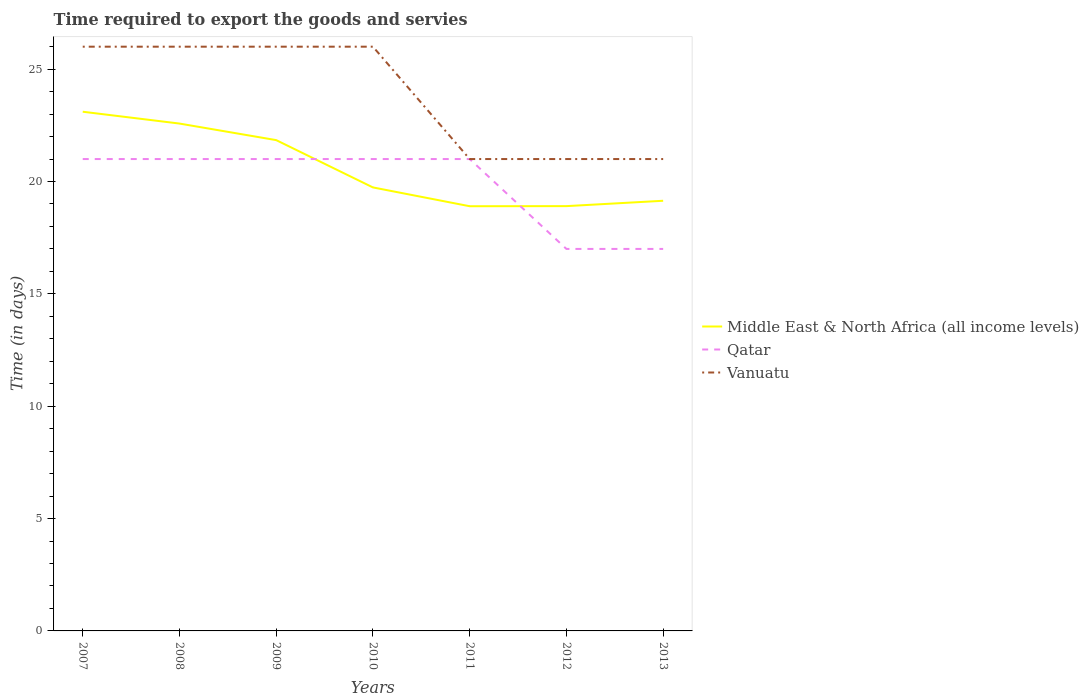Does the line corresponding to Vanuatu intersect with the line corresponding to Qatar?
Give a very brief answer. Yes. Is the number of lines equal to the number of legend labels?
Provide a short and direct response. Yes. Across all years, what is the maximum number of days required to export the goods and services in Vanuatu?
Give a very brief answer. 21. What is the total number of days required to export the goods and services in Middle East & North Africa (all income levels) in the graph?
Make the answer very short. 3.96. What is the difference between the highest and the second highest number of days required to export the goods and services in Vanuatu?
Give a very brief answer. 5. What is the difference between the highest and the lowest number of days required to export the goods and services in Vanuatu?
Give a very brief answer. 4. Is the number of days required to export the goods and services in Qatar strictly greater than the number of days required to export the goods and services in Middle East & North Africa (all income levels) over the years?
Provide a short and direct response. No. How many lines are there?
Your response must be concise. 3. How many years are there in the graph?
Your answer should be very brief. 7. What is the difference between two consecutive major ticks on the Y-axis?
Provide a succinct answer. 5. Are the values on the major ticks of Y-axis written in scientific E-notation?
Give a very brief answer. No. Does the graph contain any zero values?
Provide a succinct answer. No. Where does the legend appear in the graph?
Keep it short and to the point. Center right. How are the legend labels stacked?
Offer a terse response. Vertical. What is the title of the graph?
Your answer should be compact. Time required to export the goods and servies. Does "Monaco" appear as one of the legend labels in the graph?
Provide a succinct answer. No. What is the label or title of the Y-axis?
Your response must be concise. Time (in days). What is the Time (in days) in Middle East & North Africa (all income levels) in 2007?
Offer a very short reply. 23.11. What is the Time (in days) of Vanuatu in 2007?
Offer a terse response. 26. What is the Time (in days) of Middle East & North Africa (all income levels) in 2008?
Keep it short and to the point. 22.58. What is the Time (in days) of Middle East & North Africa (all income levels) in 2009?
Make the answer very short. 21.84. What is the Time (in days) in Qatar in 2009?
Keep it short and to the point. 21. What is the Time (in days) of Middle East & North Africa (all income levels) in 2010?
Your response must be concise. 19.74. What is the Time (in days) in Vanuatu in 2010?
Offer a very short reply. 26. What is the Time (in days) in Qatar in 2011?
Give a very brief answer. 21. What is the Time (in days) in Middle East & North Africa (all income levels) in 2012?
Offer a terse response. 18.9. What is the Time (in days) in Qatar in 2012?
Offer a terse response. 17. What is the Time (in days) of Middle East & North Africa (all income levels) in 2013?
Make the answer very short. 19.14. What is the Time (in days) of Qatar in 2013?
Provide a succinct answer. 17. What is the Time (in days) in Vanuatu in 2013?
Offer a terse response. 21. Across all years, what is the maximum Time (in days) of Middle East & North Africa (all income levels)?
Make the answer very short. 23.11. Across all years, what is the maximum Time (in days) in Qatar?
Provide a succinct answer. 21. Across all years, what is the maximum Time (in days) of Vanuatu?
Give a very brief answer. 26. Across all years, what is the minimum Time (in days) in Middle East & North Africa (all income levels)?
Your answer should be very brief. 18.9. Across all years, what is the minimum Time (in days) of Qatar?
Keep it short and to the point. 17. What is the total Time (in days) of Middle East & North Africa (all income levels) in the graph?
Your answer should be very brief. 144.21. What is the total Time (in days) of Qatar in the graph?
Your response must be concise. 139. What is the total Time (in days) in Vanuatu in the graph?
Make the answer very short. 167. What is the difference between the Time (in days) of Middle East & North Africa (all income levels) in 2007 and that in 2008?
Make the answer very short. 0.53. What is the difference between the Time (in days) in Vanuatu in 2007 and that in 2008?
Keep it short and to the point. 0. What is the difference between the Time (in days) in Middle East & North Africa (all income levels) in 2007 and that in 2009?
Make the answer very short. 1.26. What is the difference between the Time (in days) of Qatar in 2007 and that in 2009?
Offer a terse response. 0. What is the difference between the Time (in days) of Middle East & North Africa (all income levels) in 2007 and that in 2010?
Keep it short and to the point. 3.37. What is the difference between the Time (in days) in Middle East & North Africa (all income levels) in 2007 and that in 2011?
Provide a succinct answer. 4.21. What is the difference between the Time (in days) of Qatar in 2007 and that in 2011?
Ensure brevity in your answer.  0. What is the difference between the Time (in days) in Vanuatu in 2007 and that in 2011?
Offer a terse response. 5. What is the difference between the Time (in days) of Middle East & North Africa (all income levels) in 2007 and that in 2012?
Keep it short and to the point. 4.2. What is the difference between the Time (in days) of Middle East & North Africa (all income levels) in 2007 and that in 2013?
Ensure brevity in your answer.  3.96. What is the difference between the Time (in days) of Vanuatu in 2007 and that in 2013?
Your response must be concise. 5. What is the difference between the Time (in days) in Middle East & North Africa (all income levels) in 2008 and that in 2009?
Your response must be concise. 0.74. What is the difference between the Time (in days) of Vanuatu in 2008 and that in 2009?
Offer a terse response. 0. What is the difference between the Time (in days) in Middle East & North Africa (all income levels) in 2008 and that in 2010?
Your response must be concise. 2.84. What is the difference between the Time (in days) of Middle East & North Africa (all income levels) in 2008 and that in 2011?
Your answer should be very brief. 3.68. What is the difference between the Time (in days) of Qatar in 2008 and that in 2011?
Your answer should be compact. 0. What is the difference between the Time (in days) of Vanuatu in 2008 and that in 2011?
Offer a very short reply. 5. What is the difference between the Time (in days) in Middle East & North Africa (all income levels) in 2008 and that in 2012?
Provide a short and direct response. 3.67. What is the difference between the Time (in days) in Middle East & North Africa (all income levels) in 2008 and that in 2013?
Give a very brief answer. 3.44. What is the difference between the Time (in days) of Middle East & North Africa (all income levels) in 2009 and that in 2010?
Keep it short and to the point. 2.11. What is the difference between the Time (in days) in Vanuatu in 2009 and that in 2010?
Offer a terse response. 0. What is the difference between the Time (in days) in Middle East & North Africa (all income levels) in 2009 and that in 2011?
Your answer should be very brief. 2.94. What is the difference between the Time (in days) in Middle East & North Africa (all income levels) in 2009 and that in 2012?
Your response must be concise. 2.94. What is the difference between the Time (in days) of Middle East & North Africa (all income levels) in 2009 and that in 2013?
Your answer should be very brief. 2.7. What is the difference between the Time (in days) in Qatar in 2009 and that in 2013?
Your response must be concise. 4. What is the difference between the Time (in days) in Middle East & North Africa (all income levels) in 2010 and that in 2011?
Give a very brief answer. 0.84. What is the difference between the Time (in days) in Middle East & North Africa (all income levels) in 2010 and that in 2012?
Offer a terse response. 0.83. What is the difference between the Time (in days) of Middle East & North Africa (all income levels) in 2010 and that in 2013?
Offer a terse response. 0.59. What is the difference between the Time (in days) of Qatar in 2010 and that in 2013?
Offer a terse response. 4. What is the difference between the Time (in days) in Vanuatu in 2010 and that in 2013?
Make the answer very short. 5. What is the difference between the Time (in days) of Middle East & North Africa (all income levels) in 2011 and that in 2012?
Give a very brief answer. -0. What is the difference between the Time (in days) of Middle East & North Africa (all income levels) in 2011 and that in 2013?
Your answer should be very brief. -0.24. What is the difference between the Time (in days) in Vanuatu in 2011 and that in 2013?
Keep it short and to the point. 0. What is the difference between the Time (in days) in Middle East & North Africa (all income levels) in 2012 and that in 2013?
Keep it short and to the point. -0.24. What is the difference between the Time (in days) of Vanuatu in 2012 and that in 2013?
Provide a succinct answer. 0. What is the difference between the Time (in days) of Middle East & North Africa (all income levels) in 2007 and the Time (in days) of Qatar in 2008?
Keep it short and to the point. 2.11. What is the difference between the Time (in days) of Middle East & North Africa (all income levels) in 2007 and the Time (in days) of Vanuatu in 2008?
Offer a terse response. -2.89. What is the difference between the Time (in days) of Middle East & North Africa (all income levels) in 2007 and the Time (in days) of Qatar in 2009?
Ensure brevity in your answer.  2.11. What is the difference between the Time (in days) of Middle East & North Africa (all income levels) in 2007 and the Time (in days) of Vanuatu in 2009?
Give a very brief answer. -2.89. What is the difference between the Time (in days) of Middle East & North Africa (all income levels) in 2007 and the Time (in days) of Qatar in 2010?
Make the answer very short. 2.11. What is the difference between the Time (in days) of Middle East & North Africa (all income levels) in 2007 and the Time (in days) of Vanuatu in 2010?
Provide a succinct answer. -2.89. What is the difference between the Time (in days) of Qatar in 2007 and the Time (in days) of Vanuatu in 2010?
Your response must be concise. -5. What is the difference between the Time (in days) of Middle East & North Africa (all income levels) in 2007 and the Time (in days) of Qatar in 2011?
Offer a very short reply. 2.11. What is the difference between the Time (in days) in Middle East & North Africa (all income levels) in 2007 and the Time (in days) in Vanuatu in 2011?
Make the answer very short. 2.11. What is the difference between the Time (in days) in Qatar in 2007 and the Time (in days) in Vanuatu in 2011?
Make the answer very short. 0. What is the difference between the Time (in days) in Middle East & North Africa (all income levels) in 2007 and the Time (in days) in Qatar in 2012?
Give a very brief answer. 6.11. What is the difference between the Time (in days) of Middle East & North Africa (all income levels) in 2007 and the Time (in days) of Vanuatu in 2012?
Your response must be concise. 2.11. What is the difference between the Time (in days) of Qatar in 2007 and the Time (in days) of Vanuatu in 2012?
Keep it short and to the point. 0. What is the difference between the Time (in days) of Middle East & North Africa (all income levels) in 2007 and the Time (in days) of Qatar in 2013?
Ensure brevity in your answer.  6.11. What is the difference between the Time (in days) of Middle East & North Africa (all income levels) in 2007 and the Time (in days) of Vanuatu in 2013?
Offer a terse response. 2.11. What is the difference between the Time (in days) in Middle East & North Africa (all income levels) in 2008 and the Time (in days) in Qatar in 2009?
Offer a very short reply. 1.58. What is the difference between the Time (in days) in Middle East & North Africa (all income levels) in 2008 and the Time (in days) in Vanuatu in 2009?
Provide a succinct answer. -3.42. What is the difference between the Time (in days) in Qatar in 2008 and the Time (in days) in Vanuatu in 2009?
Make the answer very short. -5. What is the difference between the Time (in days) in Middle East & North Africa (all income levels) in 2008 and the Time (in days) in Qatar in 2010?
Provide a short and direct response. 1.58. What is the difference between the Time (in days) in Middle East & North Africa (all income levels) in 2008 and the Time (in days) in Vanuatu in 2010?
Offer a terse response. -3.42. What is the difference between the Time (in days) of Qatar in 2008 and the Time (in days) of Vanuatu in 2010?
Make the answer very short. -5. What is the difference between the Time (in days) of Middle East & North Africa (all income levels) in 2008 and the Time (in days) of Qatar in 2011?
Your answer should be compact. 1.58. What is the difference between the Time (in days) of Middle East & North Africa (all income levels) in 2008 and the Time (in days) of Vanuatu in 2011?
Ensure brevity in your answer.  1.58. What is the difference between the Time (in days) of Middle East & North Africa (all income levels) in 2008 and the Time (in days) of Qatar in 2012?
Ensure brevity in your answer.  5.58. What is the difference between the Time (in days) in Middle East & North Africa (all income levels) in 2008 and the Time (in days) in Vanuatu in 2012?
Your response must be concise. 1.58. What is the difference between the Time (in days) in Qatar in 2008 and the Time (in days) in Vanuatu in 2012?
Offer a very short reply. 0. What is the difference between the Time (in days) in Middle East & North Africa (all income levels) in 2008 and the Time (in days) in Qatar in 2013?
Provide a short and direct response. 5.58. What is the difference between the Time (in days) of Middle East & North Africa (all income levels) in 2008 and the Time (in days) of Vanuatu in 2013?
Make the answer very short. 1.58. What is the difference between the Time (in days) of Middle East & North Africa (all income levels) in 2009 and the Time (in days) of Qatar in 2010?
Offer a terse response. 0.84. What is the difference between the Time (in days) of Middle East & North Africa (all income levels) in 2009 and the Time (in days) of Vanuatu in 2010?
Provide a succinct answer. -4.16. What is the difference between the Time (in days) in Middle East & North Africa (all income levels) in 2009 and the Time (in days) in Qatar in 2011?
Your answer should be very brief. 0.84. What is the difference between the Time (in days) of Middle East & North Africa (all income levels) in 2009 and the Time (in days) of Vanuatu in 2011?
Provide a short and direct response. 0.84. What is the difference between the Time (in days) of Middle East & North Africa (all income levels) in 2009 and the Time (in days) of Qatar in 2012?
Give a very brief answer. 4.84. What is the difference between the Time (in days) in Middle East & North Africa (all income levels) in 2009 and the Time (in days) in Vanuatu in 2012?
Ensure brevity in your answer.  0.84. What is the difference between the Time (in days) of Qatar in 2009 and the Time (in days) of Vanuatu in 2012?
Provide a short and direct response. 0. What is the difference between the Time (in days) in Middle East & North Africa (all income levels) in 2009 and the Time (in days) in Qatar in 2013?
Provide a short and direct response. 4.84. What is the difference between the Time (in days) of Middle East & North Africa (all income levels) in 2009 and the Time (in days) of Vanuatu in 2013?
Give a very brief answer. 0.84. What is the difference between the Time (in days) in Middle East & North Africa (all income levels) in 2010 and the Time (in days) in Qatar in 2011?
Ensure brevity in your answer.  -1.26. What is the difference between the Time (in days) of Middle East & North Africa (all income levels) in 2010 and the Time (in days) of Vanuatu in 2011?
Keep it short and to the point. -1.26. What is the difference between the Time (in days) in Middle East & North Africa (all income levels) in 2010 and the Time (in days) in Qatar in 2012?
Provide a succinct answer. 2.74. What is the difference between the Time (in days) of Middle East & North Africa (all income levels) in 2010 and the Time (in days) of Vanuatu in 2012?
Keep it short and to the point. -1.26. What is the difference between the Time (in days) of Qatar in 2010 and the Time (in days) of Vanuatu in 2012?
Give a very brief answer. 0. What is the difference between the Time (in days) in Middle East & North Africa (all income levels) in 2010 and the Time (in days) in Qatar in 2013?
Provide a short and direct response. 2.74. What is the difference between the Time (in days) in Middle East & North Africa (all income levels) in 2010 and the Time (in days) in Vanuatu in 2013?
Your answer should be compact. -1.26. What is the difference between the Time (in days) of Qatar in 2011 and the Time (in days) of Vanuatu in 2012?
Provide a short and direct response. 0. What is the difference between the Time (in days) in Middle East & North Africa (all income levels) in 2011 and the Time (in days) in Qatar in 2013?
Your answer should be very brief. 1.9. What is the difference between the Time (in days) of Middle East & North Africa (all income levels) in 2011 and the Time (in days) of Vanuatu in 2013?
Keep it short and to the point. -2.1. What is the difference between the Time (in days) of Middle East & North Africa (all income levels) in 2012 and the Time (in days) of Qatar in 2013?
Your response must be concise. 1.9. What is the difference between the Time (in days) in Middle East & North Africa (all income levels) in 2012 and the Time (in days) in Vanuatu in 2013?
Ensure brevity in your answer.  -2.1. What is the average Time (in days) in Middle East & North Africa (all income levels) per year?
Offer a terse response. 20.6. What is the average Time (in days) of Qatar per year?
Your answer should be compact. 19.86. What is the average Time (in days) in Vanuatu per year?
Your answer should be very brief. 23.86. In the year 2007, what is the difference between the Time (in days) in Middle East & North Africa (all income levels) and Time (in days) in Qatar?
Ensure brevity in your answer.  2.11. In the year 2007, what is the difference between the Time (in days) of Middle East & North Africa (all income levels) and Time (in days) of Vanuatu?
Offer a terse response. -2.89. In the year 2007, what is the difference between the Time (in days) in Qatar and Time (in days) in Vanuatu?
Offer a terse response. -5. In the year 2008, what is the difference between the Time (in days) in Middle East & North Africa (all income levels) and Time (in days) in Qatar?
Provide a short and direct response. 1.58. In the year 2008, what is the difference between the Time (in days) in Middle East & North Africa (all income levels) and Time (in days) in Vanuatu?
Your answer should be compact. -3.42. In the year 2009, what is the difference between the Time (in days) in Middle East & North Africa (all income levels) and Time (in days) in Qatar?
Offer a very short reply. 0.84. In the year 2009, what is the difference between the Time (in days) in Middle East & North Africa (all income levels) and Time (in days) in Vanuatu?
Offer a terse response. -4.16. In the year 2010, what is the difference between the Time (in days) in Middle East & North Africa (all income levels) and Time (in days) in Qatar?
Offer a very short reply. -1.26. In the year 2010, what is the difference between the Time (in days) in Middle East & North Africa (all income levels) and Time (in days) in Vanuatu?
Your response must be concise. -6.26. In the year 2010, what is the difference between the Time (in days) in Qatar and Time (in days) in Vanuatu?
Give a very brief answer. -5. In the year 2011, what is the difference between the Time (in days) of Middle East & North Africa (all income levels) and Time (in days) of Qatar?
Make the answer very short. -2.1. In the year 2012, what is the difference between the Time (in days) in Middle East & North Africa (all income levels) and Time (in days) in Qatar?
Ensure brevity in your answer.  1.9. In the year 2012, what is the difference between the Time (in days) in Middle East & North Africa (all income levels) and Time (in days) in Vanuatu?
Make the answer very short. -2.1. In the year 2013, what is the difference between the Time (in days) in Middle East & North Africa (all income levels) and Time (in days) in Qatar?
Offer a very short reply. 2.14. In the year 2013, what is the difference between the Time (in days) in Middle East & North Africa (all income levels) and Time (in days) in Vanuatu?
Make the answer very short. -1.86. What is the ratio of the Time (in days) in Middle East & North Africa (all income levels) in 2007 to that in 2008?
Your answer should be very brief. 1.02. What is the ratio of the Time (in days) in Qatar in 2007 to that in 2008?
Make the answer very short. 1. What is the ratio of the Time (in days) in Vanuatu in 2007 to that in 2008?
Give a very brief answer. 1. What is the ratio of the Time (in days) in Middle East & North Africa (all income levels) in 2007 to that in 2009?
Your answer should be very brief. 1.06. What is the ratio of the Time (in days) in Qatar in 2007 to that in 2009?
Your response must be concise. 1. What is the ratio of the Time (in days) in Vanuatu in 2007 to that in 2009?
Provide a succinct answer. 1. What is the ratio of the Time (in days) in Middle East & North Africa (all income levels) in 2007 to that in 2010?
Make the answer very short. 1.17. What is the ratio of the Time (in days) in Vanuatu in 2007 to that in 2010?
Offer a terse response. 1. What is the ratio of the Time (in days) in Middle East & North Africa (all income levels) in 2007 to that in 2011?
Your answer should be very brief. 1.22. What is the ratio of the Time (in days) of Qatar in 2007 to that in 2011?
Make the answer very short. 1. What is the ratio of the Time (in days) in Vanuatu in 2007 to that in 2011?
Your answer should be very brief. 1.24. What is the ratio of the Time (in days) in Middle East & North Africa (all income levels) in 2007 to that in 2012?
Offer a very short reply. 1.22. What is the ratio of the Time (in days) of Qatar in 2007 to that in 2012?
Give a very brief answer. 1.24. What is the ratio of the Time (in days) of Vanuatu in 2007 to that in 2012?
Provide a short and direct response. 1.24. What is the ratio of the Time (in days) in Middle East & North Africa (all income levels) in 2007 to that in 2013?
Give a very brief answer. 1.21. What is the ratio of the Time (in days) in Qatar in 2007 to that in 2013?
Provide a short and direct response. 1.24. What is the ratio of the Time (in days) of Vanuatu in 2007 to that in 2013?
Make the answer very short. 1.24. What is the ratio of the Time (in days) of Middle East & North Africa (all income levels) in 2008 to that in 2009?
Offer a terse response. 1.03. What is the ratio of the Time (in days) in Qatar in 2008 to that in 2009?
Provide a succinct answer. 1. What is the ratio of the Time (in days) of Middle East & North Africa (all income levels) in 2008 to that in 2010?
Provide a succinct answer. 1.14. What is the ratio of the Time (in days) of Vanuatu in 2008 to that in 2010?
Your answer should be very brief. 1. What is the ratio of the Time (in days) of Middle East & North Africa (all income levels) in 2008 to that in 2011?
Your response must be concise. 1.19. What is the ratio of the Time (in days) in Vanuatu in 2008 to that in 2011?
Ensure brevity in your answer.  1.24. What is the ratio of the Time (in days) of Middle East & North Africa (all income levels) in 2008 to that in 2012?
Provide a succinct answer. 1.19. What is the ratio of the Time (in days) of Qatar in 2008 to that in 2012?
Give a very brief answer. 1.24. What is the ratio of the Time (in days) of Vanuatu in 2008 to that in 2012?
Provide a succinct answer. 1.24. What is the ratio of the Time (in days) in Middle East & North Africa (all income levels) in 2008 to that in 2013?
Your response must be concise. 1.18. What is the ratio of the Time (in days) in Qatar in 2008 to that in 2013?
Your answer should be compact. 1.24. What is the ratio of the Time (in days) in Vanuatu in 2008 to that in 2013?
Ensure brevity in your answer.  1.24. What is the ratio of the Time (in days) of Middle East & North Africa (all income levels) in 2009 to that in 2010?
Ensure brevity in your answer.  1.11. What is the ratio of the Time (in days) in Vanuatu in 2009 to that in 2010?
Give a very brief answer. 1. What is the ratio of the Time (in days) in Middle East & North Africa (all income levels) in 2009 to that in 2011?
Make the answer very short. 1.16. What is the ratio of the Time (in days) in Vanuatu in 2009 to that in 2011?
Provide a short and direct response. 1.24. What is the ratio of the Time (in days) in Middle East & North Africa (all income levels) in 2009 to that in 2012?
Offer a terse response. 1.16. What is the ratio of the Time (in days) of Qatar in 2009 to that in 2012?
Your answer should be very brief. 1.24. What is the ratio of the Time (in days) of Vanuatu in 2009 to that in 2012?
Offer a terse response. 1.24. What is the ratio of the Time (in days) in Middle East & North Africa (all income levels) in 2009 to that in 2013?
Provide a short and direct response. 1.14. What is the ratio of the Time (in days) of Qatar in 2009 to that in 2013?
Give a very brief answer. 1.24. What is the ratio of the Time (in days) in Vanuatu in 2009 to that in 2013?
Provide a succinct answer. 1.24. What is the ratio of the Time (in days) in Middle East & North Africa (all income levels) in 2010 to that in 2011?
Your answer should be compact. 1.04. What is the ratio of the Time (in days) in Qatar in 2010 to that in 2011?
Provide a succinct answer. 1. What is the ratio of the Time (in days) of Vanuatu in 2010 to that in 2011?
Offer a terse response. 1.24. What is the ratio of the Time (in days) in Middle East & North Africa (all income levels) in 2010 to that in 2012?
Your response must be concise. 1.04. What is the ratio of the Time (in days) of Qatar in 2010 to that in 2012?
Keep it short and to the point. 1.24. What is the ratio of the Time (in days) of Vanuatu in 2010 to that in 2012?
Your answer should be very brief. 1.24. What is the ratio of the Time (in days) of Middle East & North Africa (all income levels) in 2010 to that in 2013?
Make the answer very short. 1.03. What is the ratio of the Time (in days) in Qatar in 2010 to that in 2013?
Offer a terse response. 1.24. What is the ratio of the Time (in days) in Vanuatu in 2010 to that in 2013?
Provide a short and direct response. 1.24. What is the ratio of the Time (in days) of Middle East & North Africa (all income levels) in 2011 to that in 2012?
Provide a short and direct response. 1. What is the ratio of the Time (in days) in Qatar in 2011 to that in 2012?
Your answer should be very brief. 1.24. What is the ratio of the Time (in days) of Vanuatu in 2011 to that in 2012?
Offer a terse response. 1. What is the ratio of the Time (in days) in Middle East & North Africa (all income levels) in 2011 to that in 2013?
Offer a very short reply. 0.99. What is the ratio of the Time (in days) of Qatar in 2011 to that in 2013?
Offer a very short reply. 1.24. What is the ratio of the Time (in days) in Vanuatu in 2011 to that in 2013?
Provide a succinct answer. 1. What is the ratio of the Time (in days) of Middle East & North Africa (all income levels) in 2012 to that in 2013?
Offer a very short reply. 0.99. What is the difference between the highest and the second highest Time (in days) in Middle East & North Africa (all income levels)?
Offer a terse response. 0.53. What is the difference between the highest and the second highest Time (in days) of Qatar?
Provide a succinct answer. 0. What is the difference between the highest and the lowest Time (in days) in Middle East & North Africa (all income levels)?
Give a very brief answer. 4.21. What is the difference between the highest and the lowest Time (in days) in Vanuatu?
Your answer should be compact. 5. 